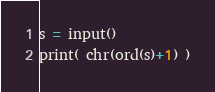Convert code to text. <code><loc_0><loc_0><loc_500><loc_500><_Python_>s = input()
print( chr(ord(s)+1) )</code> 